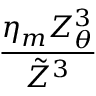<formula> <loc_0><loc_0><loc_500><loc_500>\frac { \eta _ { m } Z _ { \theta } ^ { 3 } } { \tilde { Z } ^ { 3 } }</formula> 